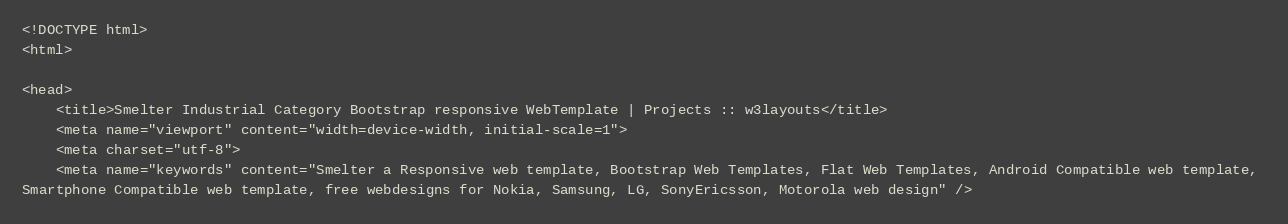Convert code to text. <code><loc_0><loc_0><loc_500><loc_500><_PHP_><!DOCTYPE html>
<html>

<head>
    <title>Smelter Industrial Category Bootstrap responsive WebTemplate | Projects :: w3layouts</title>
    <meta name="viewport" content="width=device-width, initial-scale=1">
    <meta charset="utf-8">
    <meta name="keywords" content="Smelter a Responsive web template, Bootstrap Web Templates, Flat Web Templates, Android Compatible web template, 
Smartphone Compatible web template, free webdesigns for Nokia, Samsung, LG, SonyEricsson, Motorola web design" />
</code> 